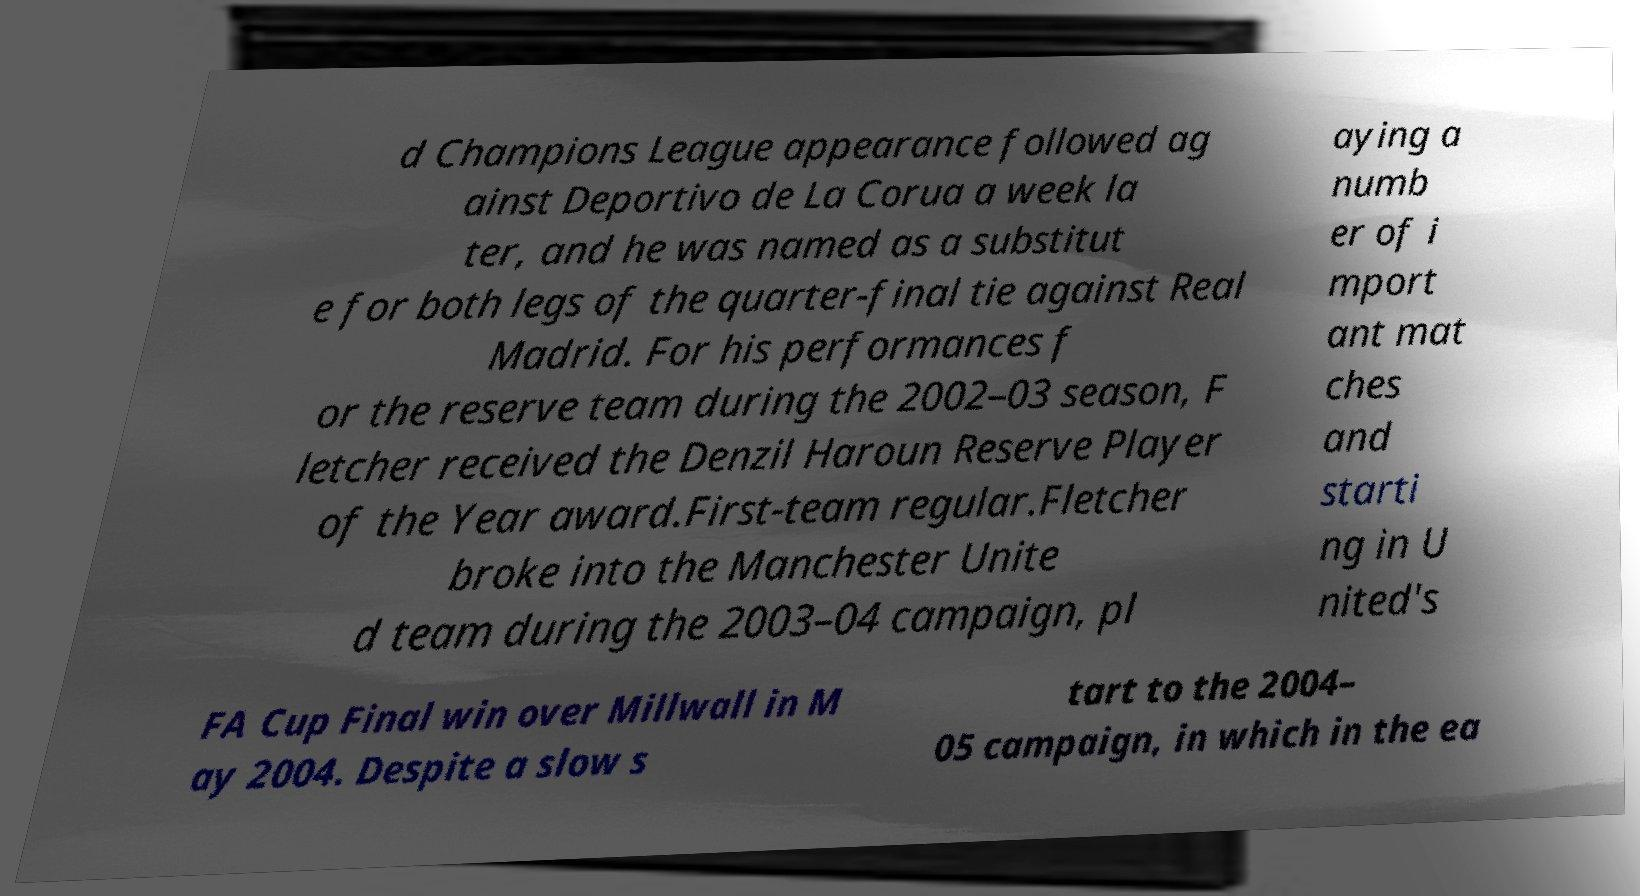Can you read and provide the text displayed in the image?This photo seems to have some interesting text. Can you extract and type it out for me? d Champions League appearance followed ag ainst Deportivo de La Corua a week la ter, and he was named as a substitut e for both legs of the quarter-final tie against Real Madrid. For his performances f or the reserve team during the 2002–03 season, F letcher received the Denzil Haroun Reserve Player of the Year award.First-team regular.Fletcher broke into the Manchester Unite d team during the 2003–04 campaign, pl aying a numb er of i mport ant mat ches and starti ng in U nited's FA Cup Final win over Millwall in M ay 2004. Despite a slow s tart to the 2004– 05 campaign, in which in the ea 